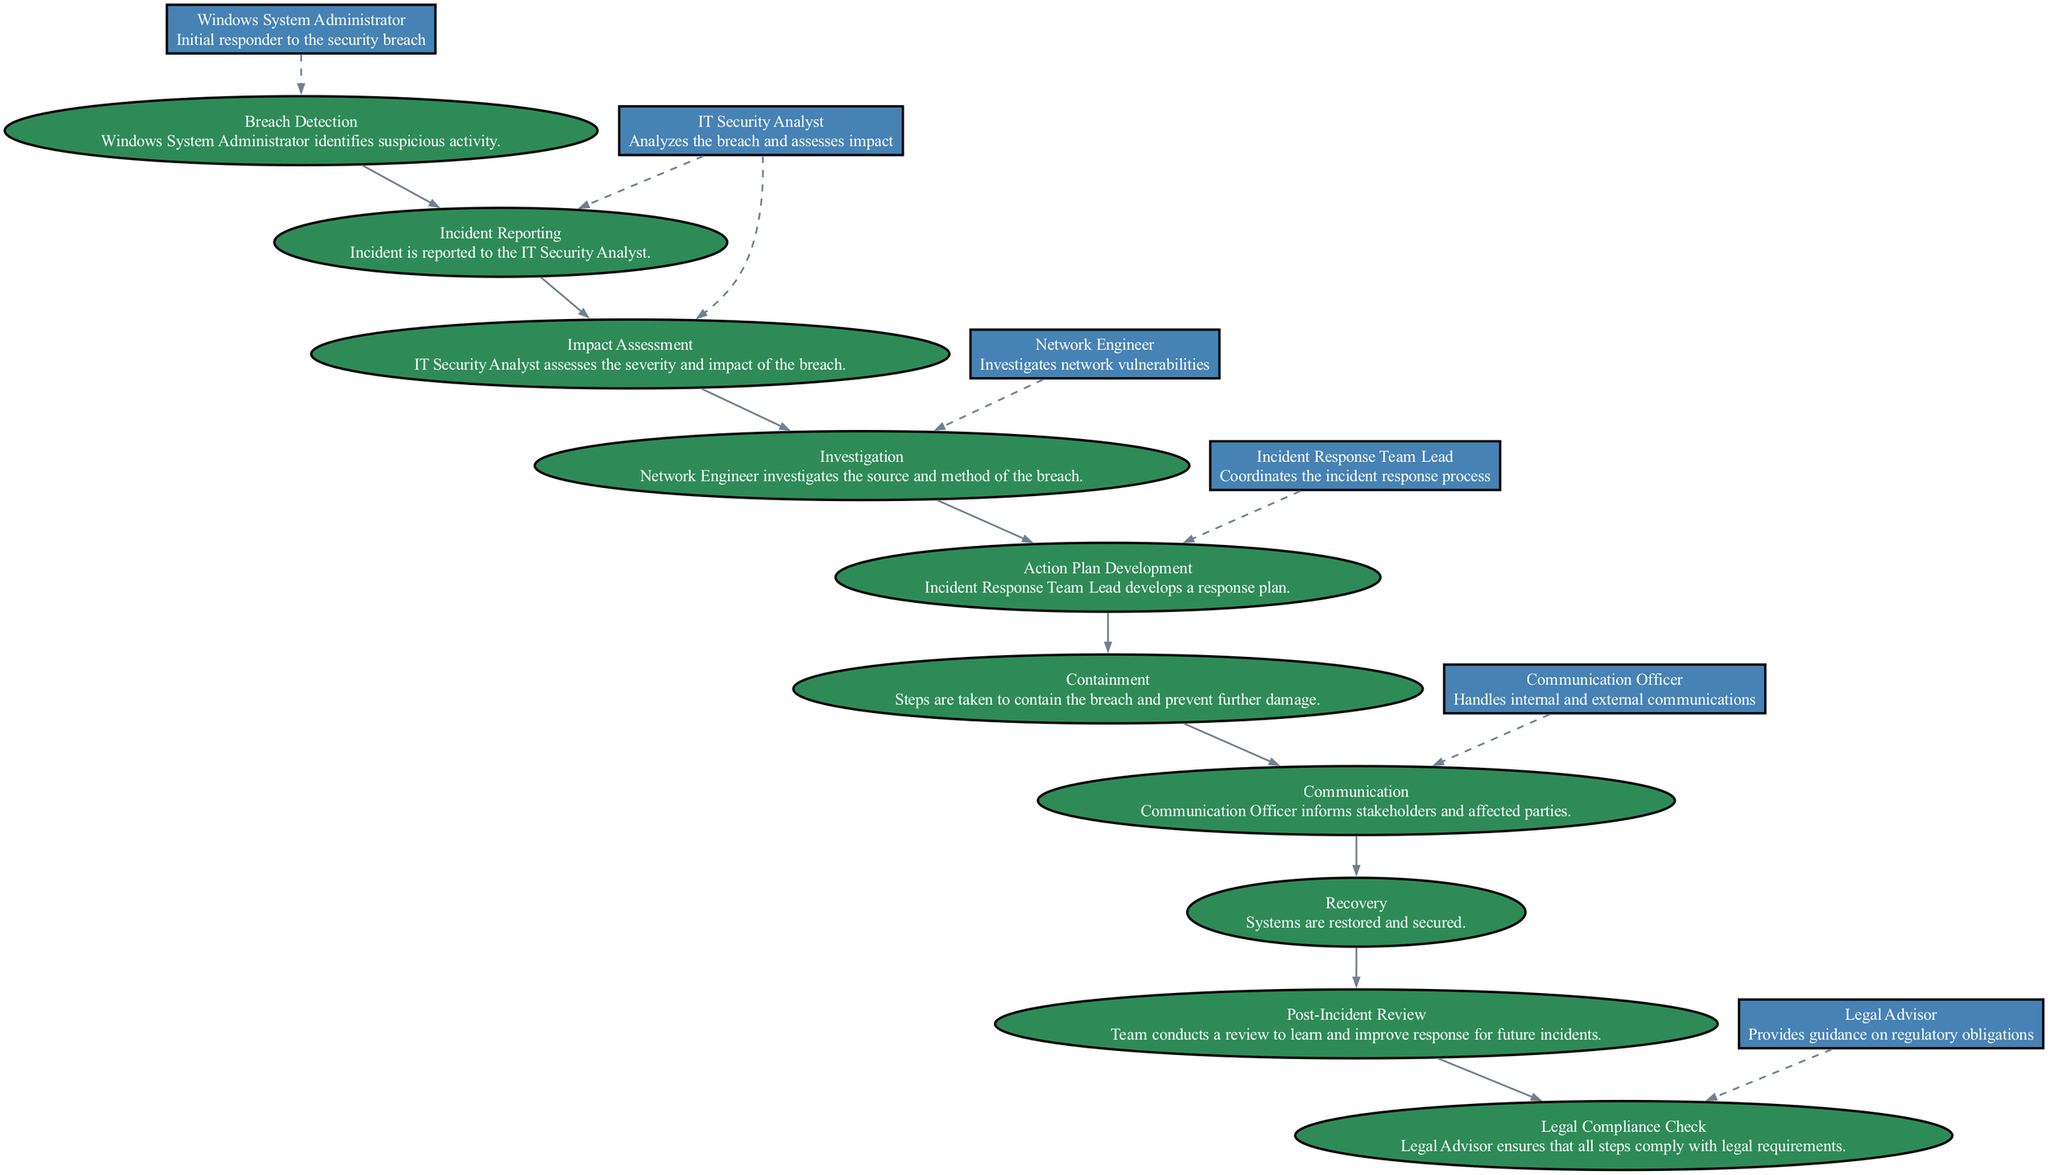What is the first step in the incident response process? The first step is "Breach Detection," where the Windows System Administrator identifies suspicious activity.
Answer: Breach Detection How many actors are involved in the incident response process? Counting the listed actors, there are six: Windows System Administrator, IT Security Analyst, Network Engineer, Incident Response Team Lead, Legal Advisor, and Communication Officer.
Answer: Six Which actor is responsible for assessing the severity of the breach? The IT Security Analyst is the actor responsible for assessing the severity and impact of the breach.
Answer: IT Security Analyst What step follows "Investigation" in the sequence of the incident response process? After "Investigation," the next step is "Action Plan Development," where the Incident Response Team Lead develops a response plan.
Answer: Action Plan Development Which step is associated with the Communication Officer? The step associated with the Communication Officer is "Communication," where stakeholders and affected parties are informed.
Answer: Communication Does the Legal Advisor have a role in the recovery process? No, the Legal Advisor's role occurs during the "Legal Compliance Check," which is a post-incident step, and is not directly involved in recovery.
Answer: No What is the final step in the incident response process? The final step is "Post-Incident Review," where the team conducts a review to learn and improve responses for future incidents.
Answer: Post-Incident Review Identify the actor who coordinates the incident response process. The Incident Response Team Lead coordinates the incident response process as part of their role.
Answer: Incident Response Team Lead Which step involves investigating network vulnerabilities? The step that involves investigating network vulnerabilities is "Investigation," performed by the Network Engineer.
Answer: Investigation 